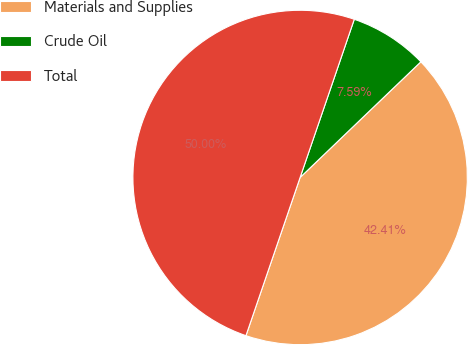Convert chart to OTSL. <chart><loc_0><loc_0><loc_500><loc_500><pie_chart><fcel>Materials and Supplies<fcel>Crude Oil<fcel>Total<nl><fcel>42.41%<fcel>7.59%<fcel>50.0%<nl></chart> 